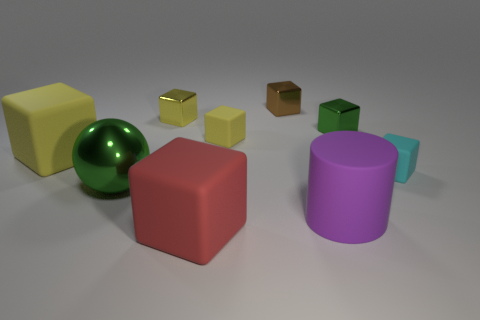What is the size of the metallic block that is the same color as the big sphere?
Provide a short and direct response. Small. Do the green block and the small brown block have the same material?
Give a very brief answer. Yes. How many tiny brown shiny blocks are to the left of the tiny metal thing that is to the left of the brown object?
Offer a very short reply. 0. How many red objects are big rubber cylinders or spheres?
Your response must be concise. 0. The yellow object in front of the matte block that is behind the matte block to the left of the small yellow shiny object is what shape?
Provide a succinct answer. Cube. What color is the matte cylinder that is the same size as the red object?
Your response must be concise. Purple. How many large yellow matte objects have the same shape as the brown thing?
Give a very brief answer. 1. There is a purple matte thing; does it have the same size as the green shiny object that is to the right of the tiny brown metallic cube?
Give a very brief answer. No. There is a green metallic object in front of the shiny thing on the right side of the small brown cube; what is its shape?
Offer a terse response. Sphere. Are there fewer big things that are on the right side of the small brown metallic object than big rubber cylinders?
Ensure brevity in your answer.  No. 